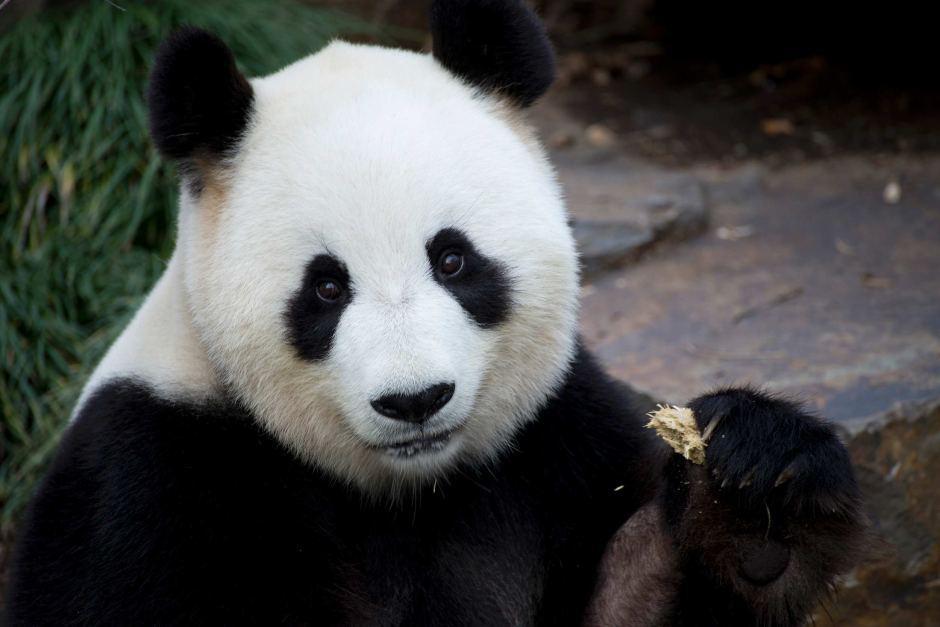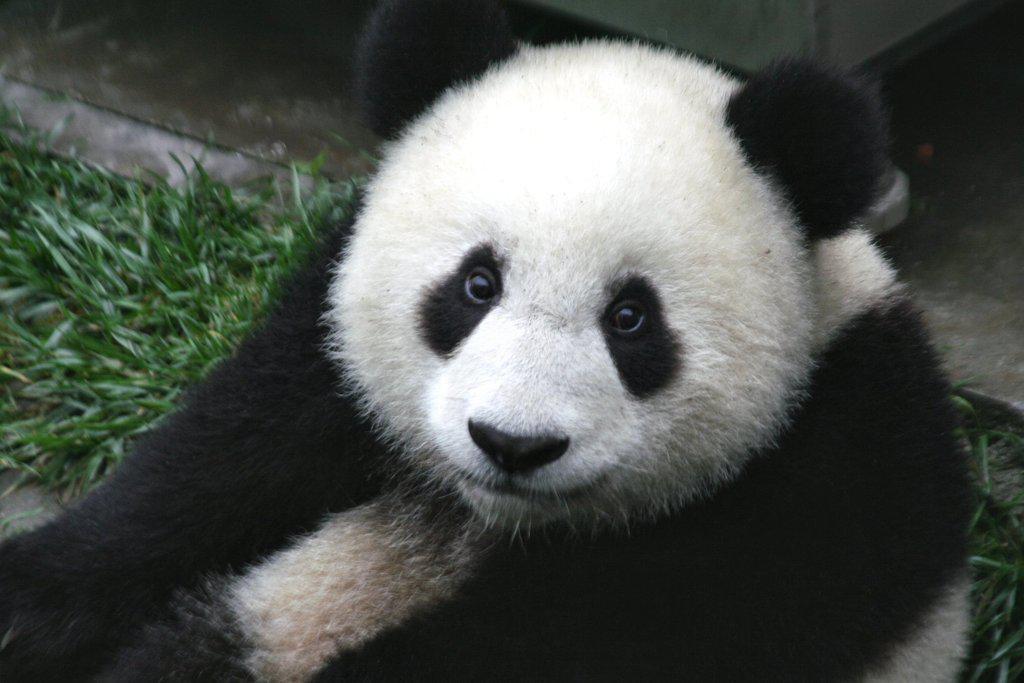The first image is the image on the left, the second image is the image on the right. Given the left and right images, does the statement "The panda in one of the images is standing on all fours in the grass." hold true? Answer yes or no. No. 